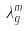<formula> <loc_0><loc_0><loc_500><loc_500>\lambda _ { g } ^ { m }</formula> 